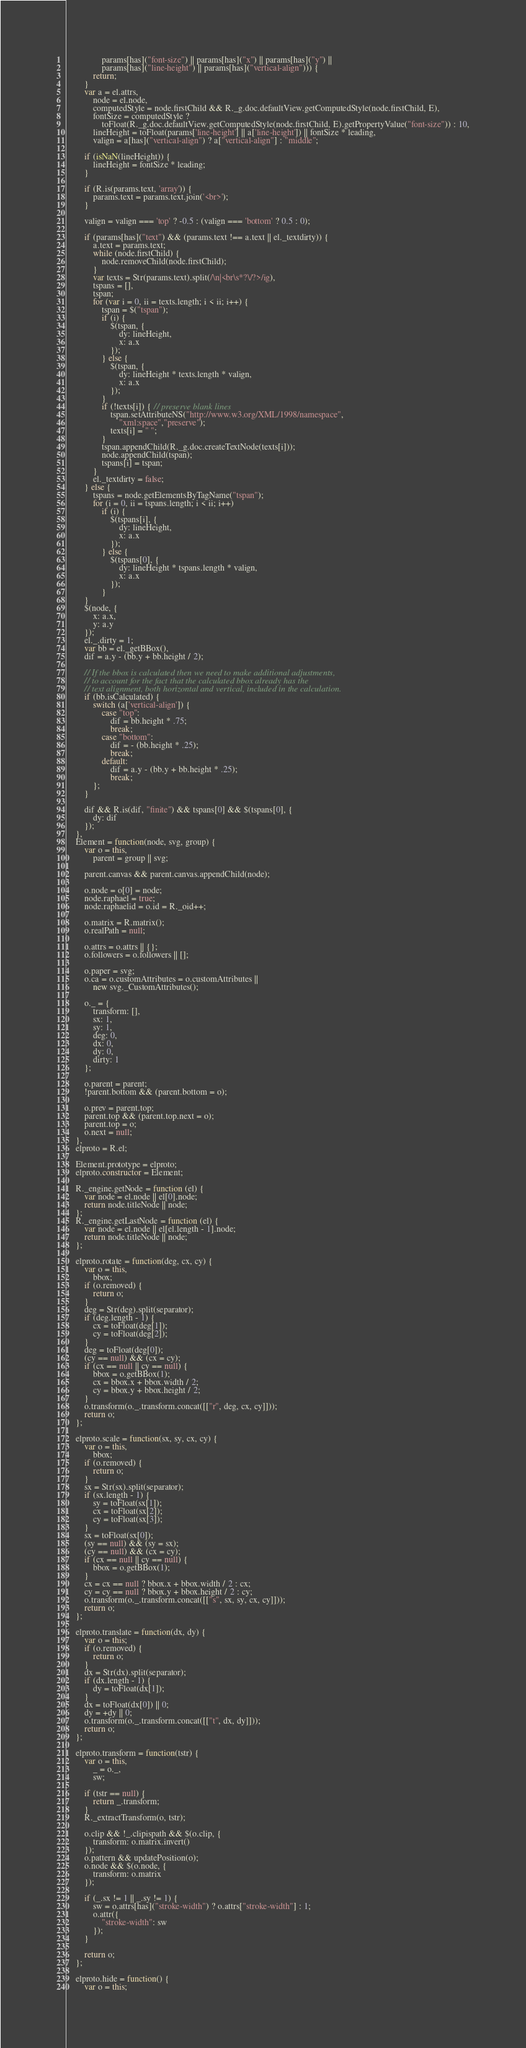Convert code to text. <code><loc_0><loc_0><loc_500><loc_500><_JavaScript_>                params[has]("font-size") || params[has]("x") || params[has]("y") ||
                params[has]("line-height") || params[has]("vertical-align"))) {
            return;
        }
        var a = el.attrs,
            node = el.node,
            computedStyle = node.firstChild && R._g.doc.defaultView.getComputedStyle(node.firstChild, E),
            fontSize = computedStyle ?
                toFloat(R._g.doc.defaultView.getComputedStyle(node.firstChild, E).getPropertyValue("font-size")) : 10,
            lineHeight = toFloat(params['line-height'] || a['line-height']) || fontSize * leading,
            valign = a[has]("vertical-align") ? a["vertical-align"] : "middle";

        if (isNaN(lineHeight)) {
            lineHeight = fontSize * leading;
        }

        if (R.is(params.text, 'array')) {
            params.text = params.text.join('<br>');
        }

        valign = valign === 'top' ? -0.5 : (valign === 'bottom' ? 0.5 : 0);

        if (params[has]("text") && (params.text !== a.text || el._textdirty)) {
            a.text = params.text;
            while (node.firstChild) {
                node.removeChild(node.firstChild);
            }
            var texts = Str(params.text).split(/\n|<br\s*?\/?>/ig),
            tspans = [],
            tspan;
            for (var i = 0, ii = texts.length; i < ii; i++) {
                tspan = $("tspan");
                if (i) {
                    $(tspan, {
                        dy: lineHeight,
                        x: a.x
                    });
                } else {
                    $(tspan, {
                        dy: lineHeight * texts.length * valign,
                        x: a.x
                    });
                }
                if (!texts[i]) { // preserve blank lines
                    tspan.setAttributeNS("http://www.w3.org/XML/1998/namespace",
                        "xml:space","preserve");
                    texts[i] = " ";
                }
                tspan.appendChild(R._g.doc.createTextNode(texts[i]));
                node.appendChild(tspan);
                tspans[i] = tspan;
            }
            el._textdirty = false;
        } else {
            tspans = node.getElementsByTagName("tspan");
            for (i = 0, ii = tspans.length; i < ii; i++)
                if (i) {
                    $(tspans[i], {
                        dy: lineHeight,
                        x: a.x
                    });
                } else {
                    $(tspans[0], {
                        dy: lineHeight * tspans.length * valign,
                        x: a.x
                    });
                }
        }
        $(node, {
            x: a.x,
            y: a.y
        });
        el._.dirty = 1;
        var bb = el._getBBox(),
        dif = a.y - (bb.y + bb.height / 2);

        // If the bbox is calculated then we need to make additional adjustments,
        // to account for the fact that the calculated bbox already has the
        // text alignment, both horizontal and vertical, included in the calculation.
        if (bb.isCalculated) {
            switch (a['vertical-align']) {
                case "top":
                    dif = bb.height * .75;
                    break;
                case "bottom":
                    dif = - (bb.height * .25);
                    break;
                default:
                    dif = a.y - (bb.y + bb.height * .25);
                    break;
            };
        }

        dif && R.is(dif, "finite") && tspans[0] && $(tspans[0], {
            dy: dif
        });
    },
    Element = function(node, svg, group) {
        var o = this,
            parent = group || svg;

        parent.canvas && parent.canvas.appendChild(node);

        o.node = o[0] = node;
        node.raphael = true;
        node.raphaelid = o.id = R._oid++;

        o.matrix = R.matrix();
        o.realPath = null;

        o.attrs = o.attrs || {};
        o.followers = o.followers || [];

        o.paper = svg;
        o.ca = o.customAttributes = o.customAttributes ||
            new svg._CustomAttributes();

        o._ = {
            transform: [],
            sx: 1,
            sy: 1,
            deg: 0,
            dx: 0,
            dy: 0,
            dirty: 1
        };

        o.parent = parent;
        !parent.bottom && (parent.bottom = o);

        o.prev = parent.top;
        parent.top && (parent.top.next = o);
        parent.top = o;
        o.next = null;
    },
    elproto = R.el;

    Element.prototype = elproto;
    elproto.constructor = Element;

    R._engine.getNode = function (el) {
        var node = el.node || el[0].node;
        return node.titleNode || node;
    };
    R._engine.getLastNode = function (el) {
        var node = el.node || el[el.length - 1].node;
        return node.titleNode || node;
    };

    elproto.rotate = function(deg, cx, cy) {
        var o = this,
            bbox;
        if (o.removed) {
            return o;
        }
        deg = Str(deg).split(separator);
        if (deg.length - 1) {
            cx = toFloat(deg[1]);
            cy = toFloat(deg[2]);
        }
        deg = toFloat(deg[0]);
        (cy == null) && (cx = cy);
        if (cx == null || cy == null) {
            bbox = o.getBBox(1);
            cx = bbox.x + bbox.width / 2;
            cy = bbox.y + bbox.height / 2;
        }
        o.transform(o._.transform.concat([["r", deg, cx, cy]]));
        return o;
    };

    elproto.scale = function(sx, sy, cx, cy) {
        var o = this,
            bbox;
        if (o.removed) {
            return o;
        }
        sx = Str(sx).split(separator);
        if (sx.length - 1) {
            sy = toFloat(sx[1]);
            cx = toFloat(sx[2]);
            cy = toFloat(sx[3]);
        }
        sx = toFloat(sx[0]);
        (sy == null) && (sy = sx);
        (cy == null) && (cx = cy);
        if (cx == null || cy == null) {
            bbox = o.getBBox(1);
        }
        cx = cx == null ? bbox.x + bbox.width / 2 : cx;
        cy = cy == null ? bbox.y + bbox.height / 2 : cy;
        o.transform(o._.transform.concat([["s", sx, sy, cx, cy]]));
        return o;
    };

    elproto.translate = function(dx, dy) {
        var o = this;
        if (o.removed) {
            return o;
        }
        dx = Str(dx).split(separator);
        if (dx.length - 1) {
            dy = toFloat(dx[1]);
        }
        dx = toFloat(dx[0]) || 0;
        dy = +dy || 0;
        o.transform(o._.transform.concat([["t", dx, dy]]));
        return o;
    };

    elproto.transform = function(tstr) {
        var o = this,
            _ = o._,
            sw;

        if (tstr == null) {
            return _.transform;
        }
        R._extractTransform(o, tstr);

        o.clip && !_.clipispath && $(o.clip, {
            transform: o.matrix.invert()
        });
        o.pattern && updatePosition(o);
        o.node && $(o.node, {
            transform: o.matrix
        });

        if (_.sx != 1 || _.sy != 1) {
            sw = o.attrs[has]("stroke-width") ? o.attrs["stroke-width"] : 1;
            o.attr({
                "stroke-width": sw
            });
        }

        return o;
    };

    elproto.hide = function() {
        var o = this;</code> 